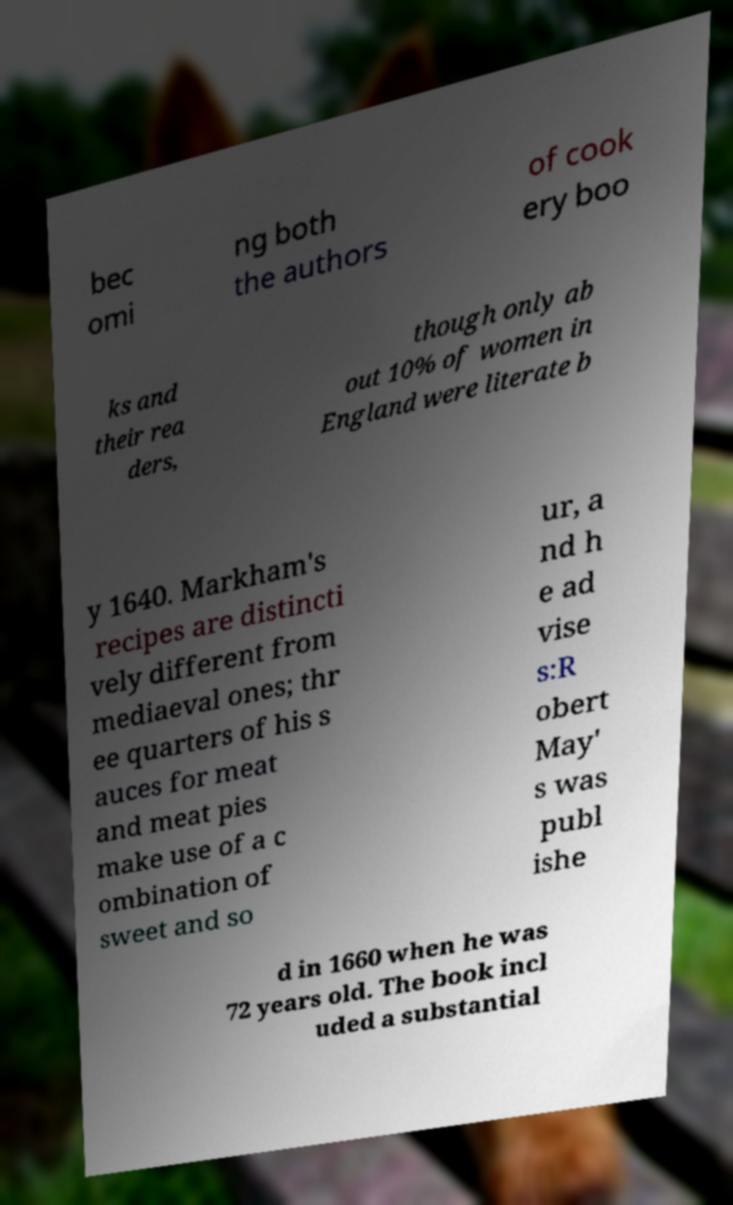Can you read and provide the text displayed in the image?This photo seems to have some interesting text. Can you extract and type it out for me? bec omi ng both the authors of cook ery boo ks and their rea ders, though only ab out 10% of women in England were literate b y 1640. Markham's recipes are distincti vely different from mediaeval ones; thr ee quarters of his s auces for meat and meat pies make use of a c ombination of sweet and so ur, a nd h e ad vise s:R obert May' s was publ ishe d in 1660 when he was 72 years old. The book incl uded a substantial 